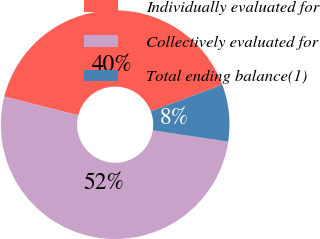<chart> <loc_0><loc_0><loc_500><loc_500><pie_chart><fcel>Individually evaluated for<fcel>Collectively evaluated for<fcel>Total ending balance(1)<nl><fcel>40.36%<fcel>51.57%<fcel>8.07%<nl></chart> 